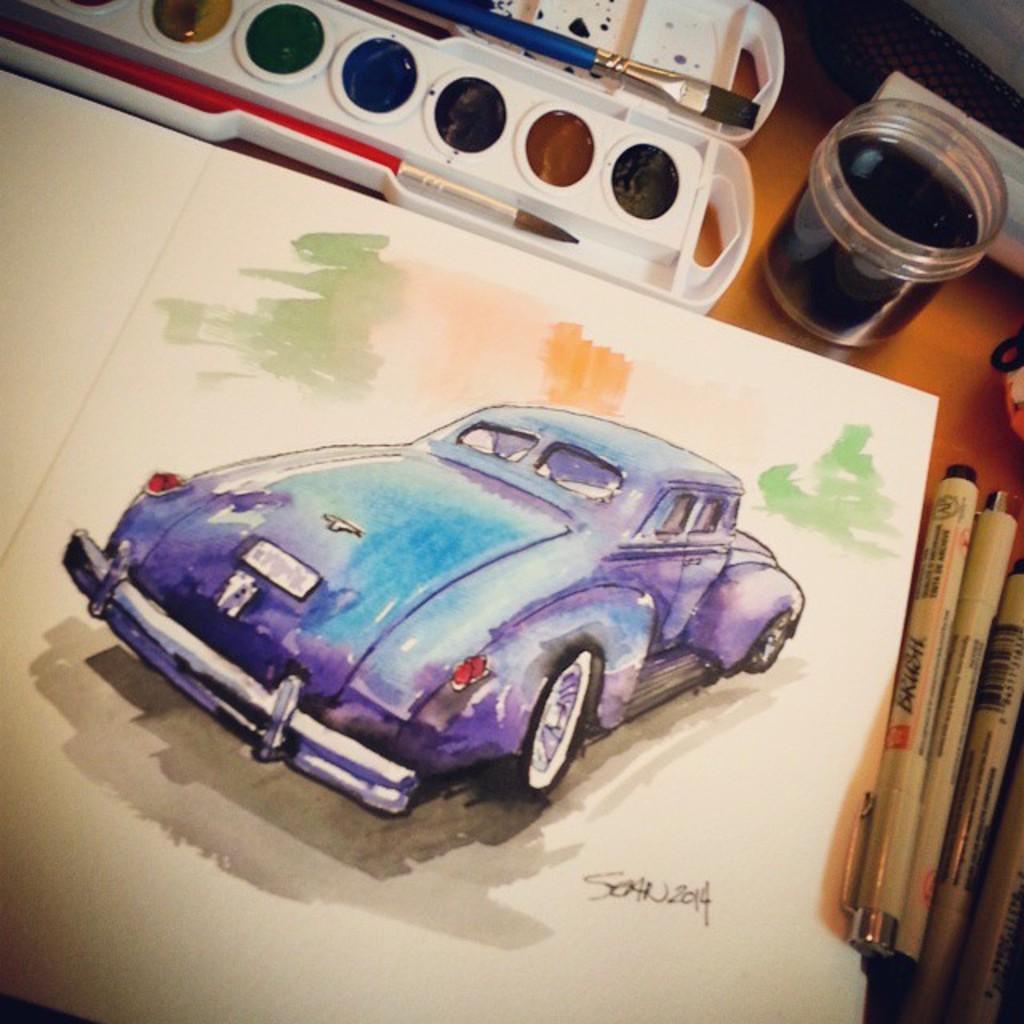Describe this image in one or two sentences. In the foreground of this image, on a wooden surface there are pens, a paper, brushes, colors, a container and few more objects. 